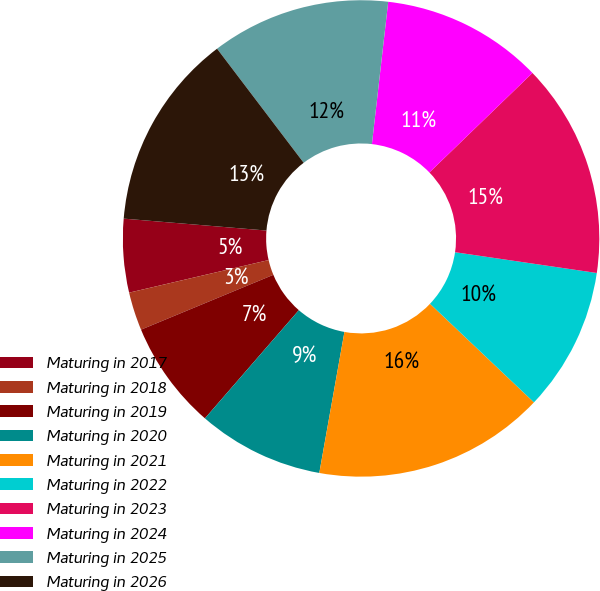<chart> <loc_0><loc_0><loc_500><loc_500><pie_chart><fcel>Maturing in 2017<fcel>Maturing in 2018<fcel>Maturing in 2019<fcel>Maturing in 2020<fcel>Maturing in 2021<fcel>Maturing in 2022<fcel>Maturing in 2023<fcel>Maturing in 2024<fcel>Maturing in 2025<fcel>Maturing in 2026<nl><fcel>4.98%<fcel>2.6%<fcel>7.37%<fcel>8.57%<fcel>15.73%<fcel>9.76%<fcel>14.54%<fcel>10.96%<fcel>12.15%<fcel>13.34%<nl></chart> 